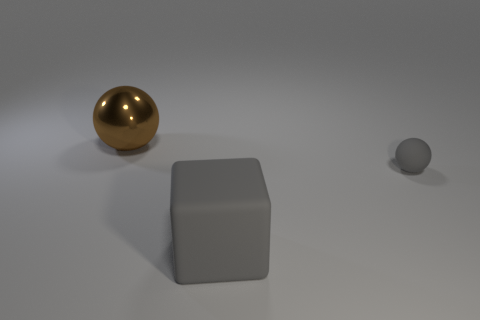Add 3 yellow shiny cylinders. How many objects exist? 6 Subtract all spheres. How many objects are left? 1 Subtract 0 red balls. How many objects are left? 3 Subtract all big matte objects. Subtract all gray rubber spheres. How many objects are left? 1 Add 2 gray rubber blocks. How many gray rubber blocks are left? 3 Add 3 big green cylinders. How many big green cylinders exist? 3 